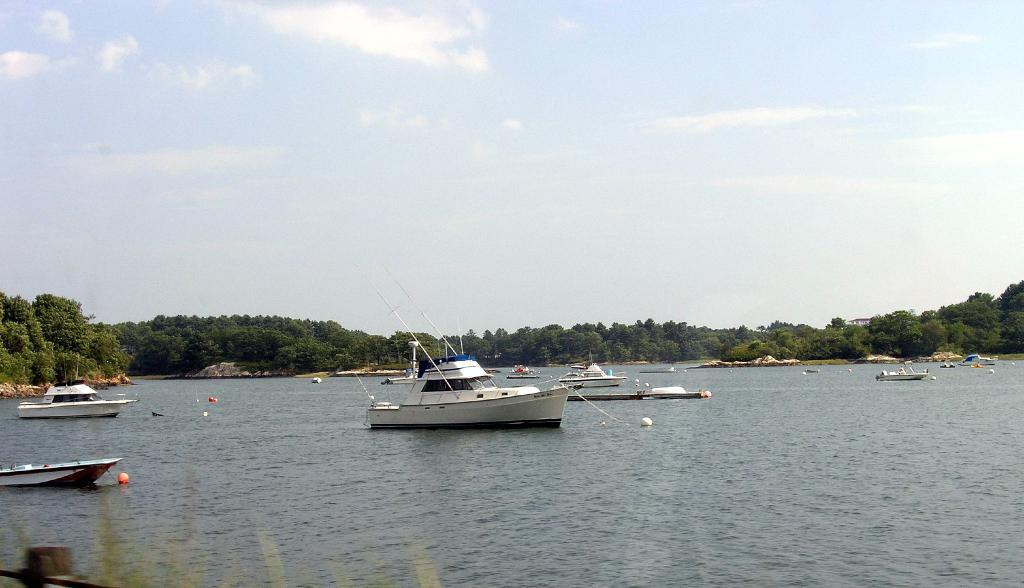What is the main feature in the foreground of the image? There is a water body in the foreground of the image. What is present in the water body? There are boats in the water. What type of vegetation can be seen in the middle of the image? There are trees in the middle of the image. What is visible at the top of the image? The sky is visible at the top of the image. What type of caption is written on the water in the image? There is no caption written on the water in the image. Can you tell me how many cups are floating in the water? There are no cups present in the image; only boats are visible in the water. 